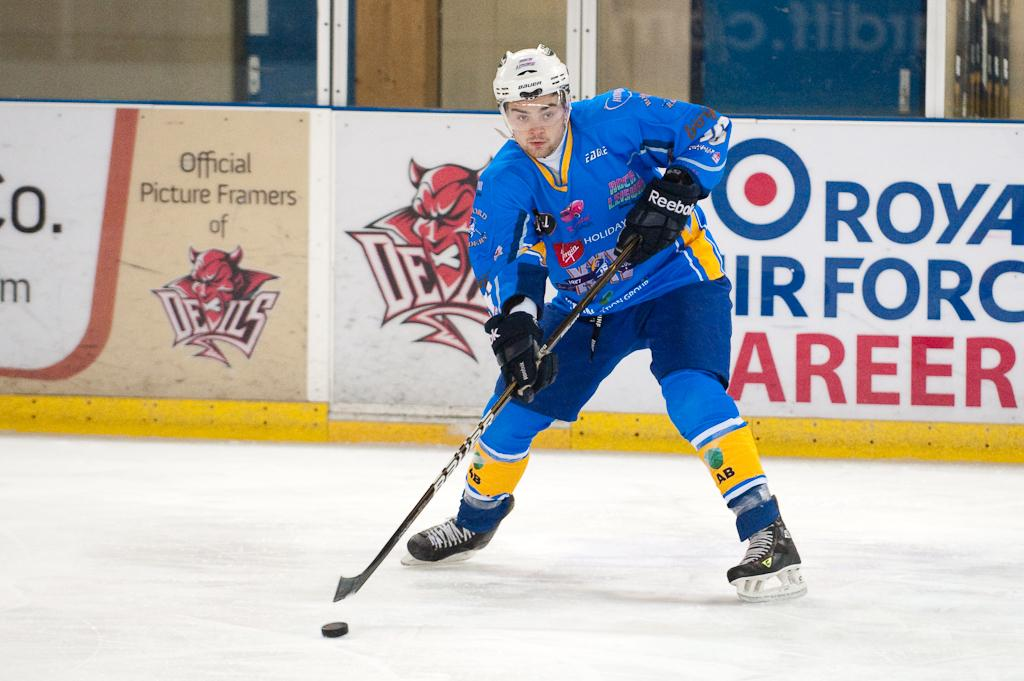Provide a one-sentence caption for the provided image. A hockey player is getting ready to shoot the puck, in front of a banner, inside the arena, advertising an Air Force career. 